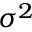Convert formula to latex. <formula><loc_0><loc_0><loc_500><loc_500>{ \sigma ^ { 2 } } \,</formula> 